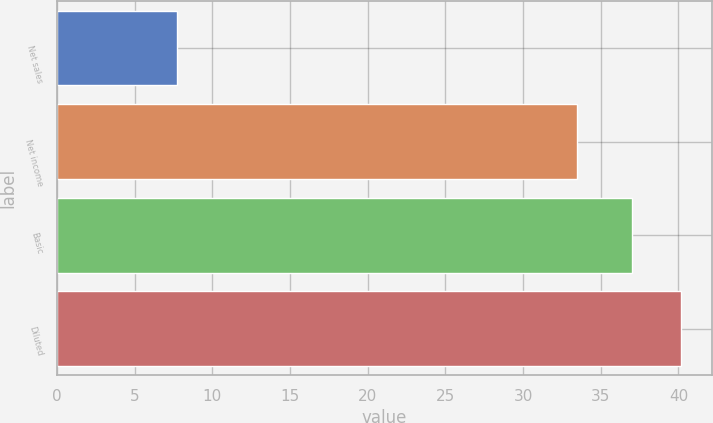Convert chart to OTSL. <chart><loc_0><loc_0><loc_500><loc_500><bar_chart><fcel>Net sales<fcel>Net income<fcel>Basic<fcel>Diluted<nl><fcel>7.7<fcel>33.5<fcel>37<fcel>40.13<nl></chart> 